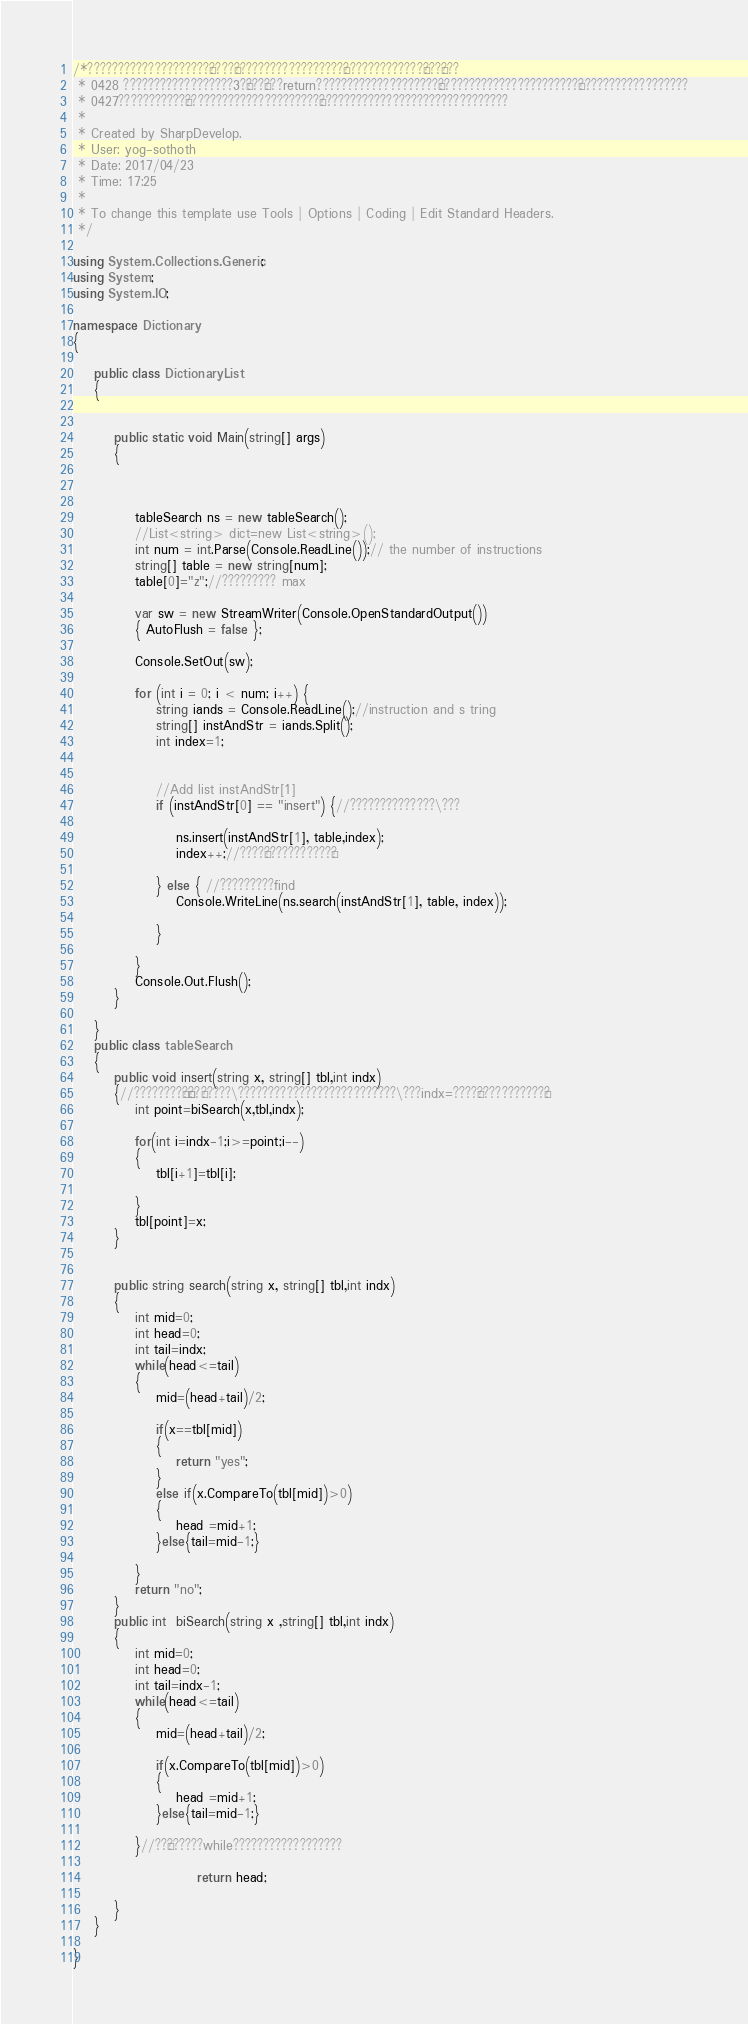<code> <loc_0><loc_0><loc_500><loc_500><_C#_>/*????????????????????§????§??????????????????§?????????????§???°???
 * 0428 ??????????????????3?§???°???return????????????????????§???????????????????????£??????????????????
 * 0427???????????¨??????????????????????´???????????????????????????????
 * 
 * Created by SharpDevelop.
 * User: yog-sothoth
 * Date: 2017/04/23
 * Time: 17:25
 * 
 * To change this template use Tools | Options | Coding | Edit Standard Headers.
 */

using System.Collections.Generic;
using System;
using System.IO;

namespace Dictionary
{
	
	public class DictionaryList
	{
		
		
		public static void Main(string[] args)
		{
		
			
		
			tableSearch ns = new tableSearch();
			//List<string> dict=new List<string>();
			int num = int.Parse(Console.ReadLine());// the number of instructions
			string[] table = new string[num];
			table[0]="z";//????????? max

			var sw = new StreamWriter(Console.OpenStandardOutput())
	    	{ AutoFlush = false };
			
			Console.SetOut(sw);
			
			for (int i = 0; i < num; i++) {
				string iands = Console.ReadLine();//instruction and s tring
				string[] instAndStr = iands.Split();
				int index=1;
				
				
				//Add list instAndStr[1]		
				if (instAndStr[0] == "insert") {//??????????????\???
					
					ns.insert(instAndStr[1], table,index);
					index++;//????°???????????´?
					
				} else { //?????????find				
					Console.WriteLine(ns.search(instAndStr[1], table, index));
					
				}
				
			}
			Console.Out.Flush();
		}
		
	}
	public class tableSearch
	{
		public void insert(string x, string[] tbl,int indx)
		{//????????¢?´¢??§?????\??????????????????????????\???indx=????°???????????´?
			int point=biSearch(x,tbl,indx);
			
			for(int i=indx-1;i>=point;i--)
			{
				tbl[i+1]=tbl[i];
					
			}
			tbl[point]=x;
		}
		
			
		public string search(string x, string[] tbl,int indx)
		{	
			int mid=0;
			int head=0;
			int tail=indx;
			while(head<=tail)
			{
				mid=(head+tail)/2;
					
				if(x==tbl[mid])
				{
					return "yes";
				}
				else if(x.CompareTo(tbl[mid])>0)
				{
					head =mid+1;
				}else{tail=mid-1;}
			
			}
			return "no";
		}
		public int  biSearch(string x ,string[] tbl,int indx)
		{
			int mid=0;
			int head=0;
			int tail=indx-1;
			while(head<=tail)
			{
				mid=(head+tail)/2;
					
				if(x.CompareTo(tbl[mid])>0)
				{
					head =mid+1;
				}else{tail=mid-1;}
			
			}//??¶??????while??????????????????
			
						return head;
				
		}
	}

}</code> 